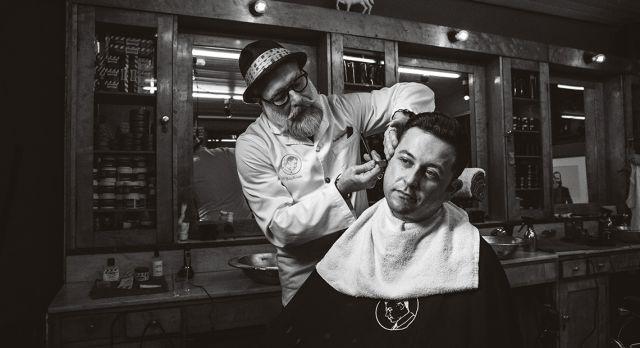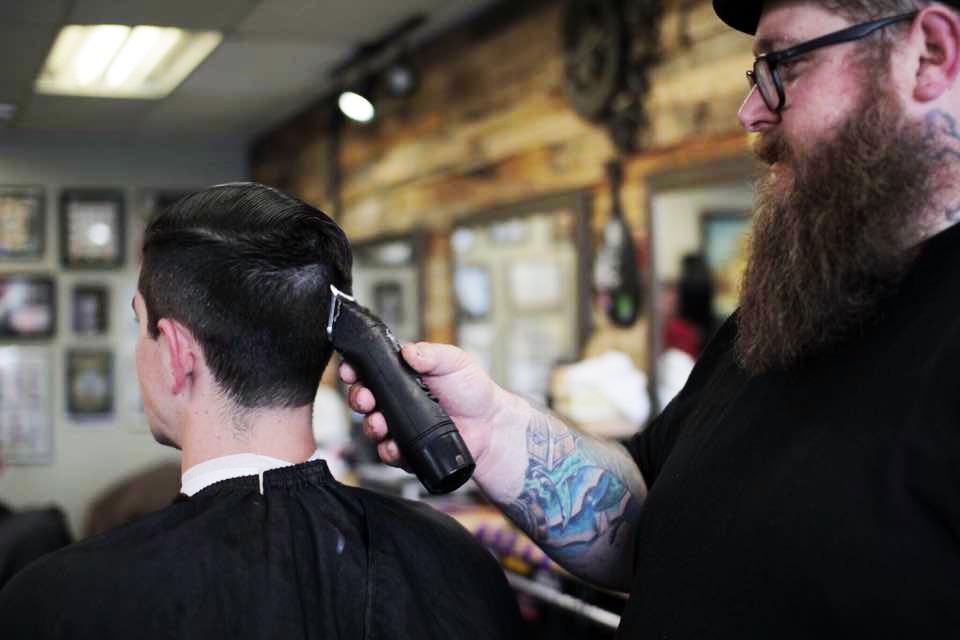The first image is the image on the left, the second image is the image on the right. Given the left and right images, does the statement "The left image includes a man in a hat, glasses and beard standing behind a forward-facing customer in a black smock." hold true? Answer yes or no. Yes. The first image is the image on the left, the second image is the image on the right. Given the left and right images, does the statement "All of these images are in black and white." hold true? Answer yes or no. No. 